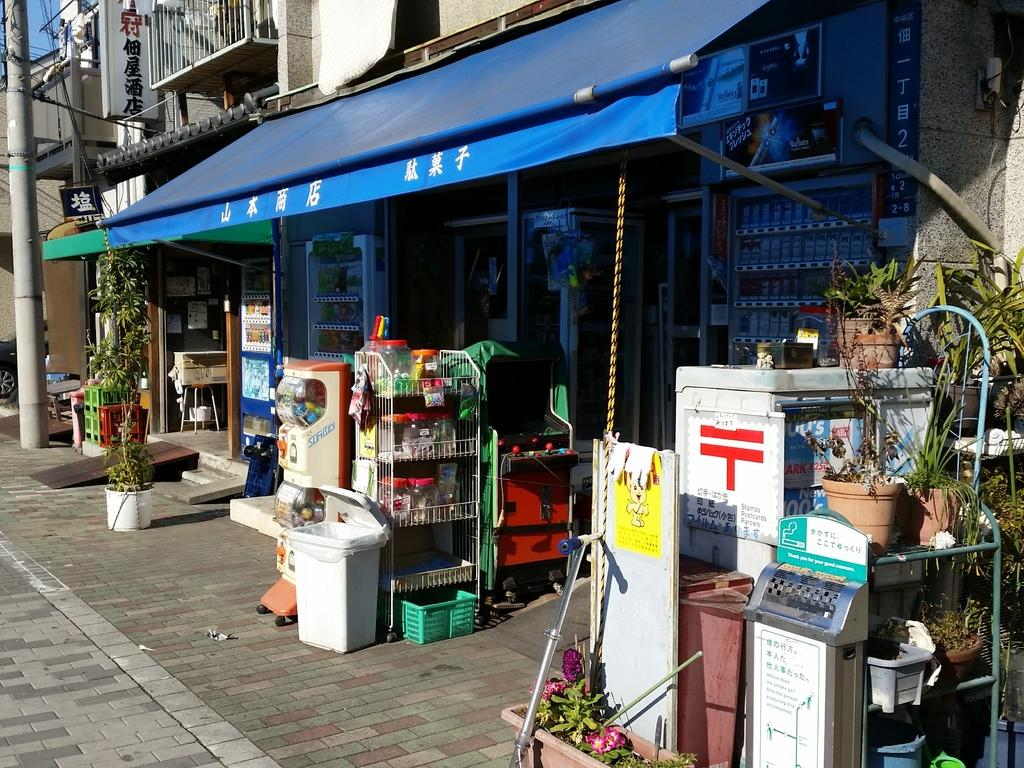Provide a one-sentence caption for the provided image. Next to the sign in Chinese is a stamps and postcards parcels. 